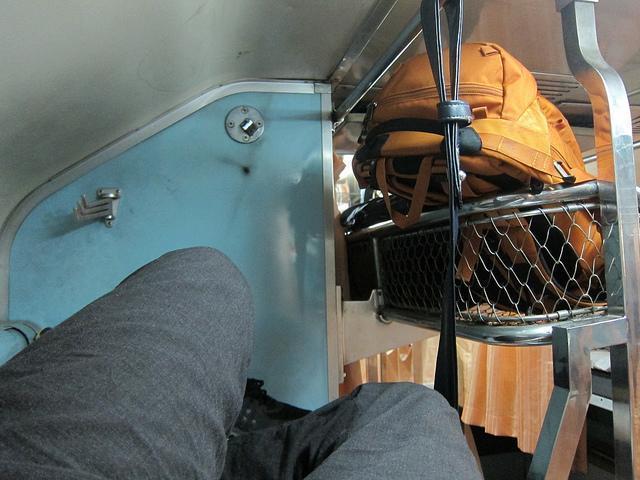How many people are in the photo?
Give a very brief answer. 1. 